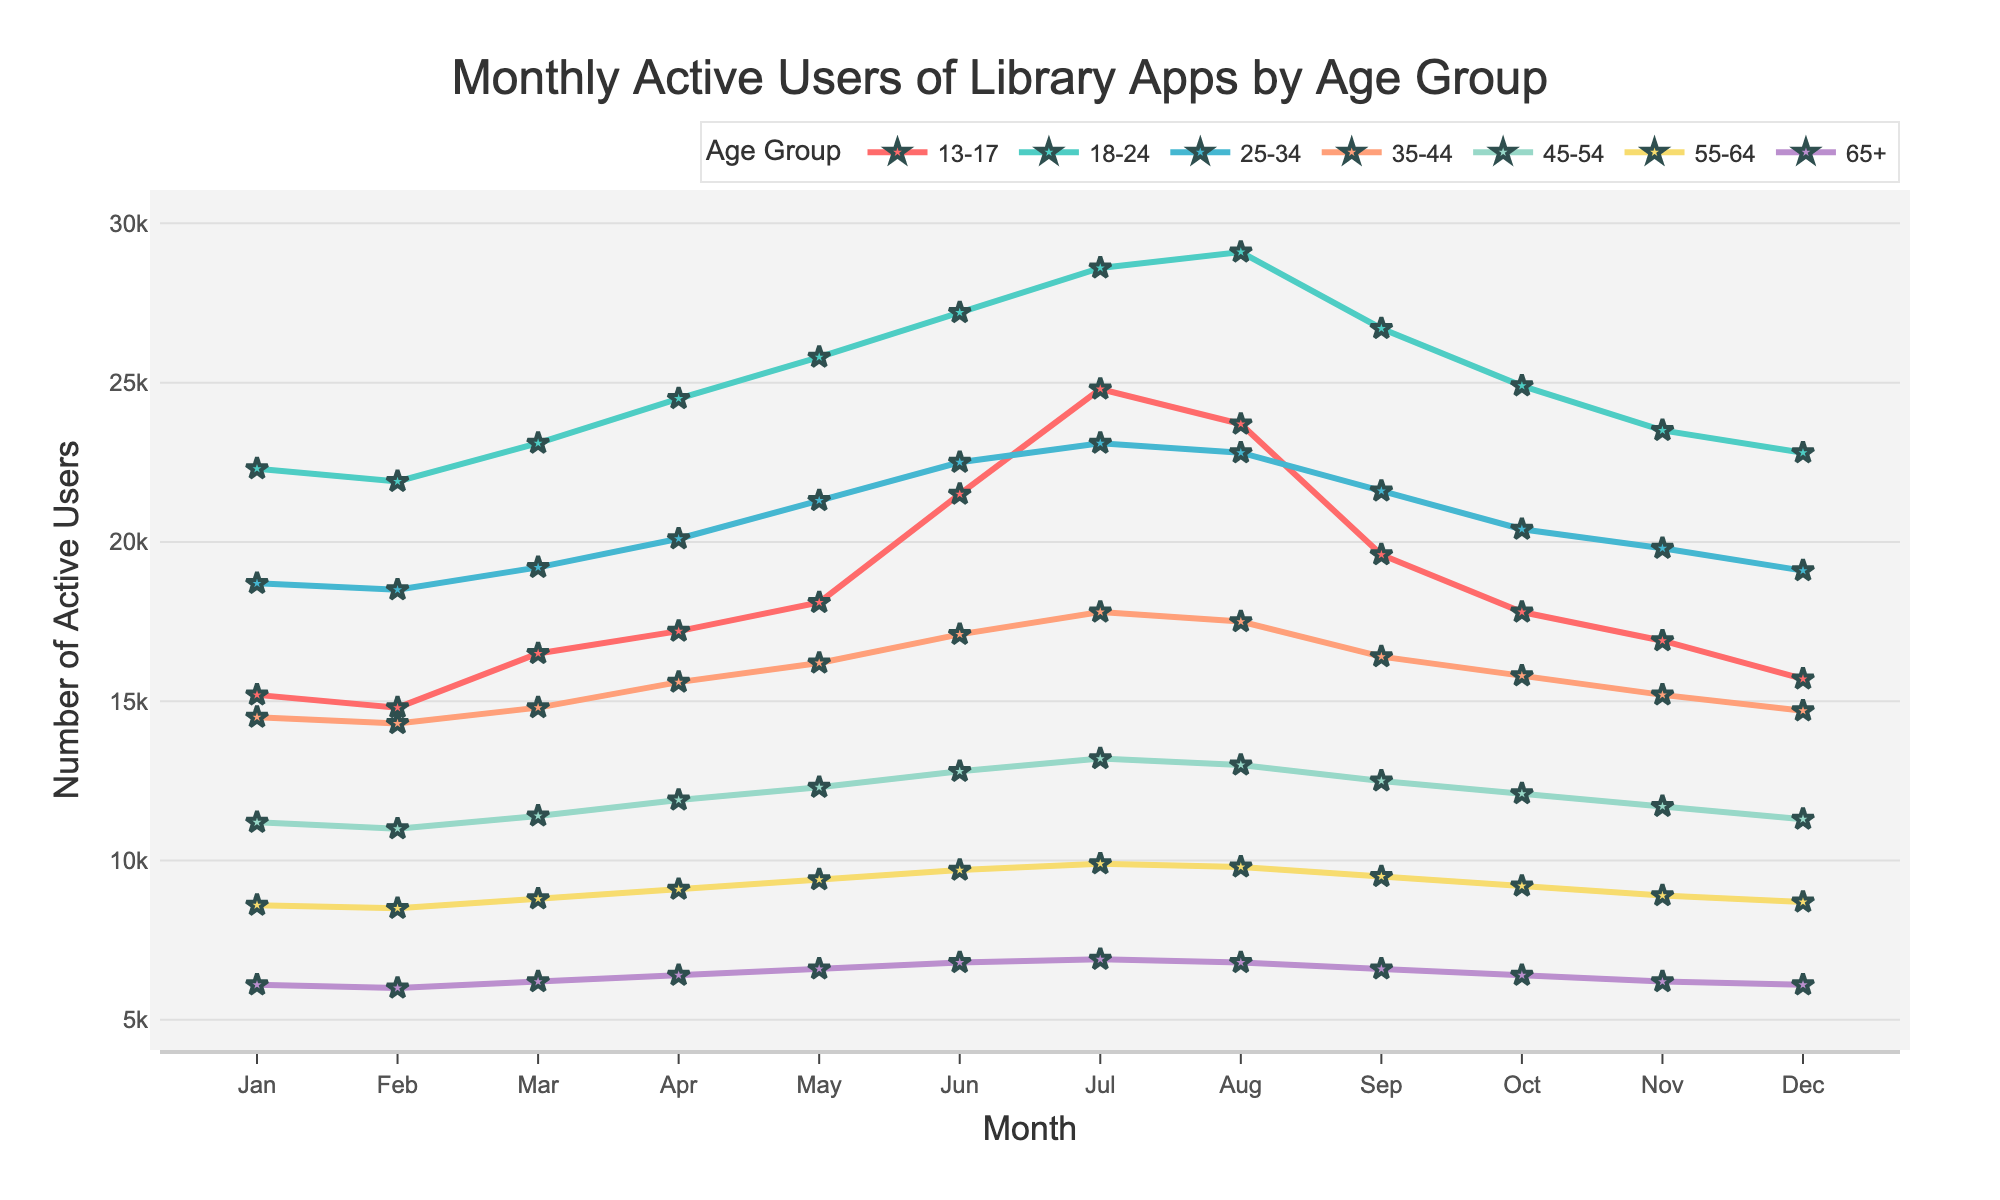What is the trend in the user activity for the 18-24 age group over the year? The 18-24 age group shows an increase in the number of active users from January to August, peaking in August, followed by a decline towards December.
Answer: Increases to August, then declines Which age group had the highest number of active users in July? Comparing the user counts for July across all age groups, the 13-17 age group had the highest number of active users, at 24,800.
Answer: 13-17 What is the difference in the number of active users between the 13-17 and 65+ age groups in June? The number of active users in June for the 13-17 group is 21,500, and for the 65+ group is 6,800. The difference is 21,500 - 6,800.
Answer: 14,700 What is the combined number of active users in December for the age groups 45-54 and 55-64? In December, the 45-54 age group has 11,300 active users and the 55-64 age group has 8,700 active users. Summing these gives 11,300 + 8,700.
Answer: 20,000 How does the usage pattern of the 35-44 group compare to the 25-34 group throughout the year? The 35-44 and 25-34 groups both show an increase in user activity until mid-year, peaking in June, but the 25-34 group consistently has higher user activity numbers throughout the year compared to the 35-44 group.
Answer: 25-34 > 35-44 consistently Which months show the highest user activity across all age groups combined? To determine the highest activity months, sum the active users for all age groups across each month and compare. The highest combined user activity is observed in June and July.
Answer: June and July What's the average number of active users in March for the age group 25-34? The number of active users in March for the 25-34 group is 19,200. Since there is only one data point, the average is the same as the value.
Answer: 19,200 Describe the trend in user activity for the 55-64 age group from Jan to Dec. The 55-64 age group shows a slight increase in user activity from January to June, peaking in July, followed by a gradual decrease from August to December.
Answer: Slight increase, peak in July, gradual decrease In terms of user retention, which age group shows the least fluctuation in user activity? By observing the lines, the age group 65+ shows the least fluctuation, as the line is relatively more stable and flatter compared to other groups.
Answer: 65+ 